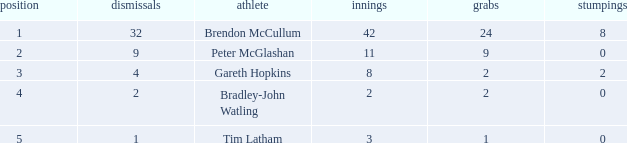How many dismissals did the player Peter McGlashan have? 9.0. 